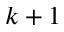Convert formula to latex. <formula><loc_0><loc_0><loc_500><loc_500>k + 1</formula> 